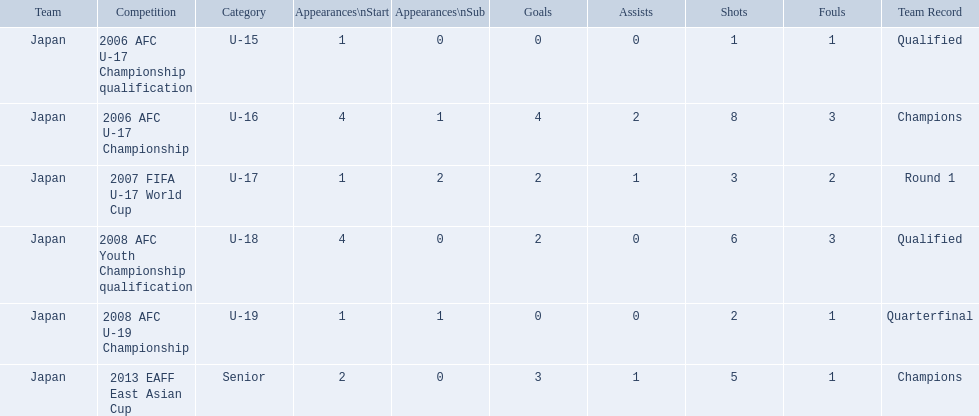What competitions did japan compete in with yoichiro kakitani? 2006 AFC U-17 Championship qualification, 2006 AFC U-17 Championship, 2007 FIFA U-17 World Cup, 2008 AFC Youth Championship qualification, 2008 AFC U-19 Championship, 2013 EAFF East Asian Cup. Of those competitions, which were held in 2007 and 2013? 2007 FIFA U-17 World Cup, 2013 EAFF East Asian Cup. Of the 2007 fifa u-17 world cup and the 2013 eaff east asian cup, which did japan have the most starting appearances? 2013 EAFF East Asian Cup. 